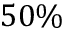Convert formula to latex. <formula><loc_0><loc_0><loc_500><loc_500>5 0 \%</formula> 